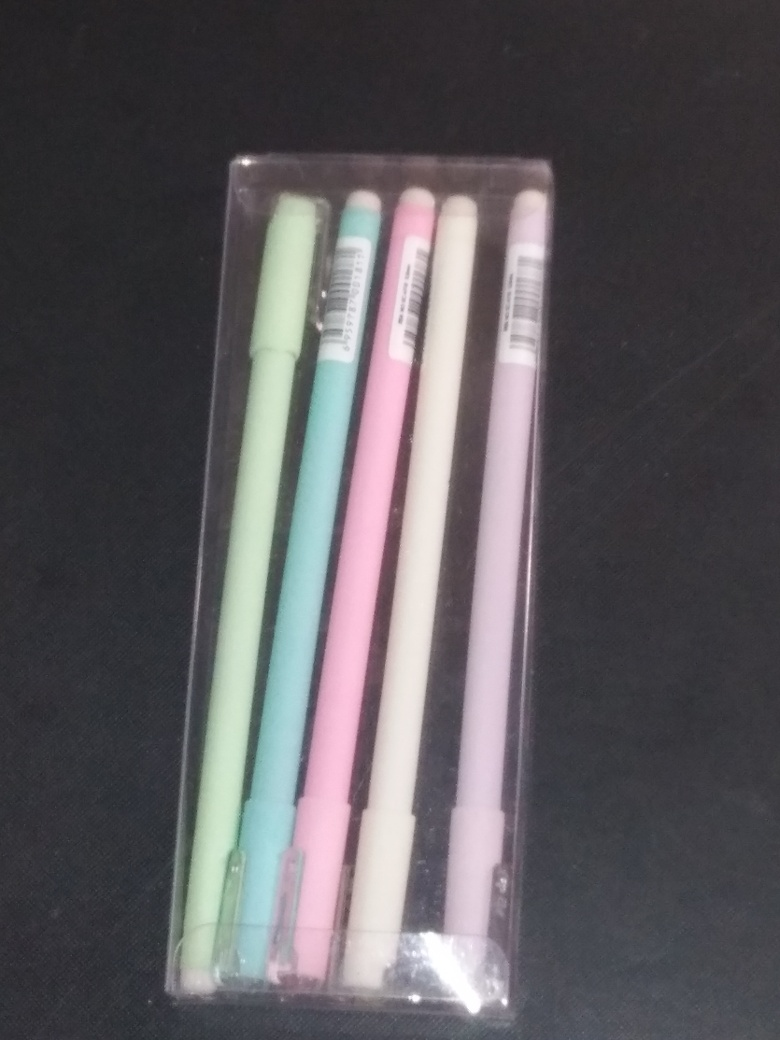What could be the potential uses for the pens shown in the image? These pens can serve various purposes. They are suitable for taking notes, especially in environments like offices or classrooms, due to their different colors, which can help in organizing content or highlighting important parts of the text. Additionally, their pastel tones make them an appealing choice for crafters or artists who enjoy adding a touch of color to their creations or planners. 